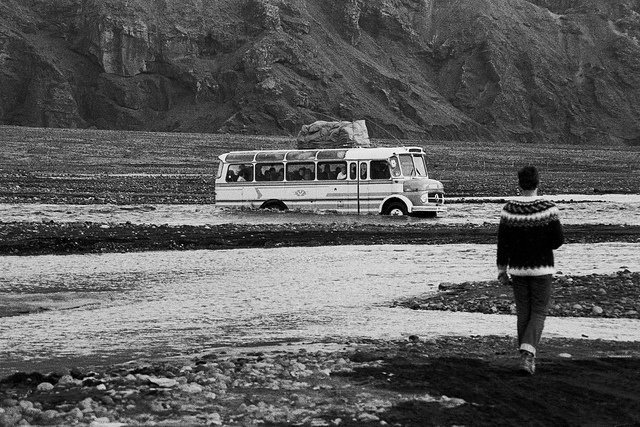Describe the objects in this image and their specific colors. I can see bus in gray, lightgray, darkgray, and black tones, people in gray, black, darkgray, and lightgray tones, people in gray, black, darkgray, and lightgray tones, people in black and gray tones, and people in black and gray tones in this image. 